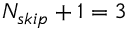<formula> <loc_0><loc_0><loc_500><loc_500>{ N _ { s k i p } + 1 } = 3</formula> 